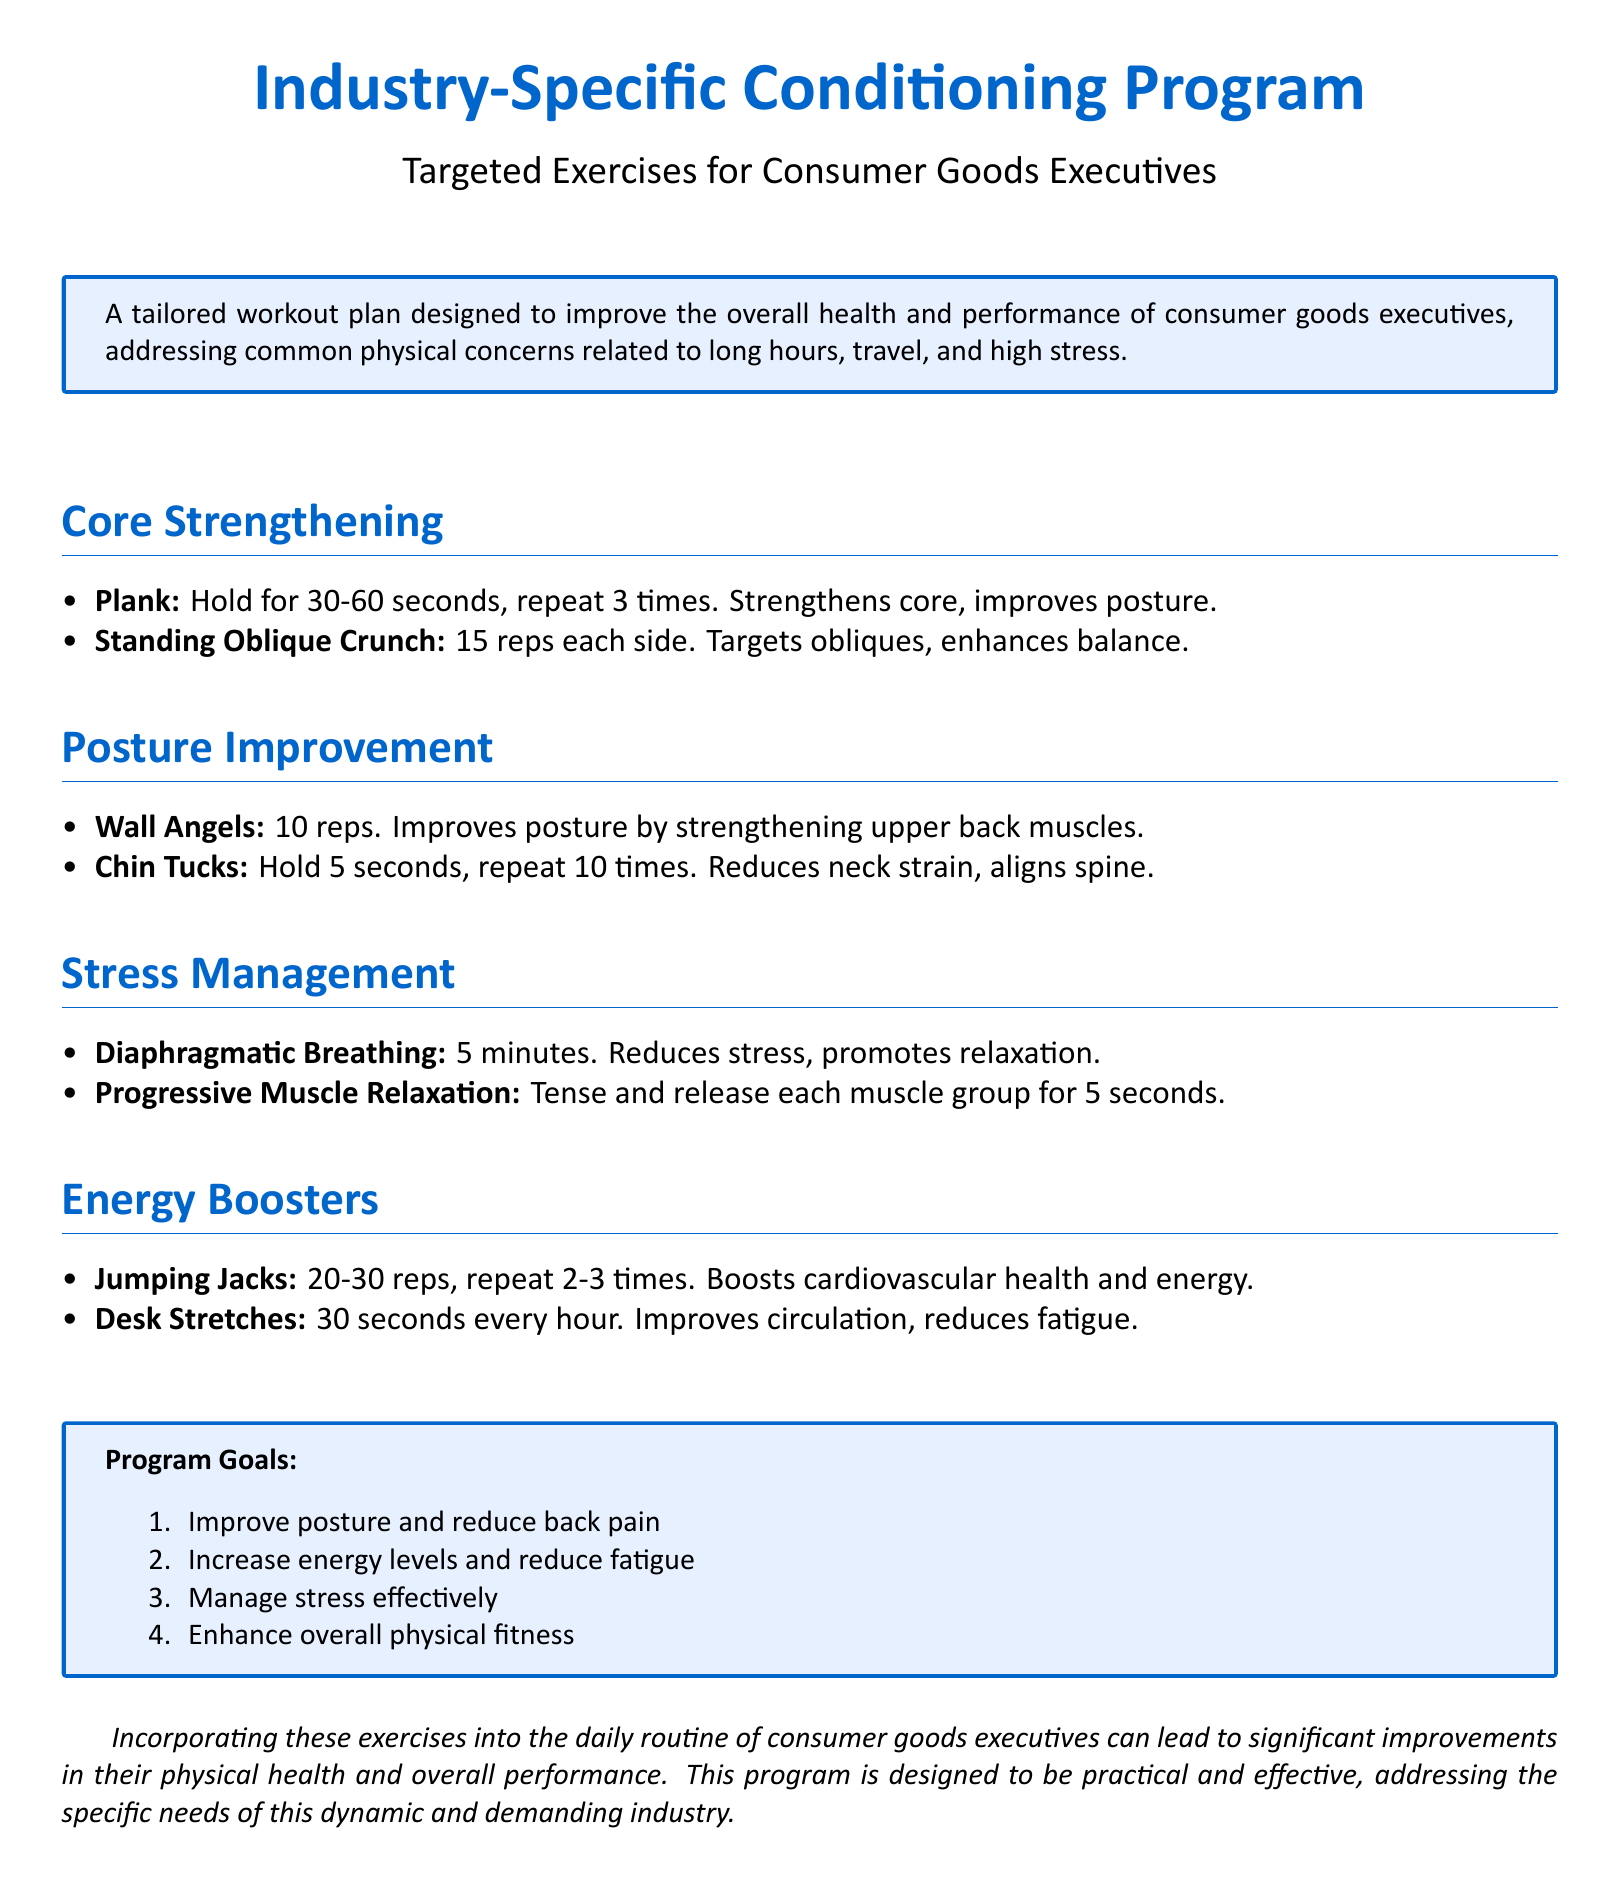What is the main purpose of the Industry-Specific Conditioning Program? The program is designed to improve the overall health and performance of consumer goods executives, addressing common physical concerns related to long hours, travel, and high stress.
Answer: Improve health and performance How long should the Plank exercise be held? The document specifies that the Plank should be held for 30-60 seconds.
Answer: 30-60 seconds What exercise is recommended to enhance posture? The Wall Angels exercise is listed as beneficial for improving posture.
Answer: Wall Angels How many reps are suggested for the Standing Oblique Crunch? The document indicates 15 reps for each side of the Standing Oblique Crunch.
Answer: 15 reps each side What does Diaphragmatic Breathing aim to reduce? The exercise aims to reduce stress and promote relaxation.
Answer: Stress How many goals does the program outline? The document lists a total of four goals for the program.
Answer: Four What is one method to improve energy levels according to the document? Jumping Jacks are suggested as a way to boost energy levels and cardiovascular health.
Answer: Jumping Jacks How many times should Desk Stretches be done each hour? The recommendation states to perform Desk Stretches for 30 seconds every hour.
Answer: 30 seconds every hour 